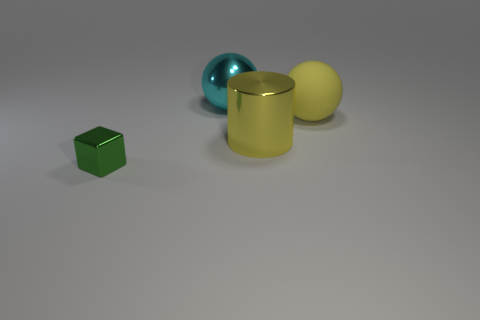Is the material of the large yellow cylinder the same as the yellow thing that is on the right side of the big shiny cylinder?
Ensure brevity in your answer.  No. The shiny cylinder that is the same color as the big rubber object is what size?
Your answer should be very brief. Large. Are there any small yellow cylinders made of the same material as the large cylinder?
Your answer should be very brief. No. How many objects are either large objects that are right of the cyan metal ball or things in front of the cyan sphere?
Offer a very short reply. 3. Does the large yellow shiny object have the same shape as the thing that is to the left of the cyan object?
Provide a succinct answer. No. What number of other objects are there of the same shape as the big rubber thing?
Provide a succinct answer. 1. What number of things are big cyan metallic blocks or small green blocks?
Your answer should be very brief. 1. Do the large matte ball and the small shiny object have the same color?
Your answer should be compact. No. Are there any other things that have the same size as the yellow shiny thing?
Offer a terse response. Yes. What is the shape of the object on the right side of the big metallic object that is in front of the rubber object?
Offer a terse response. Sphere. 